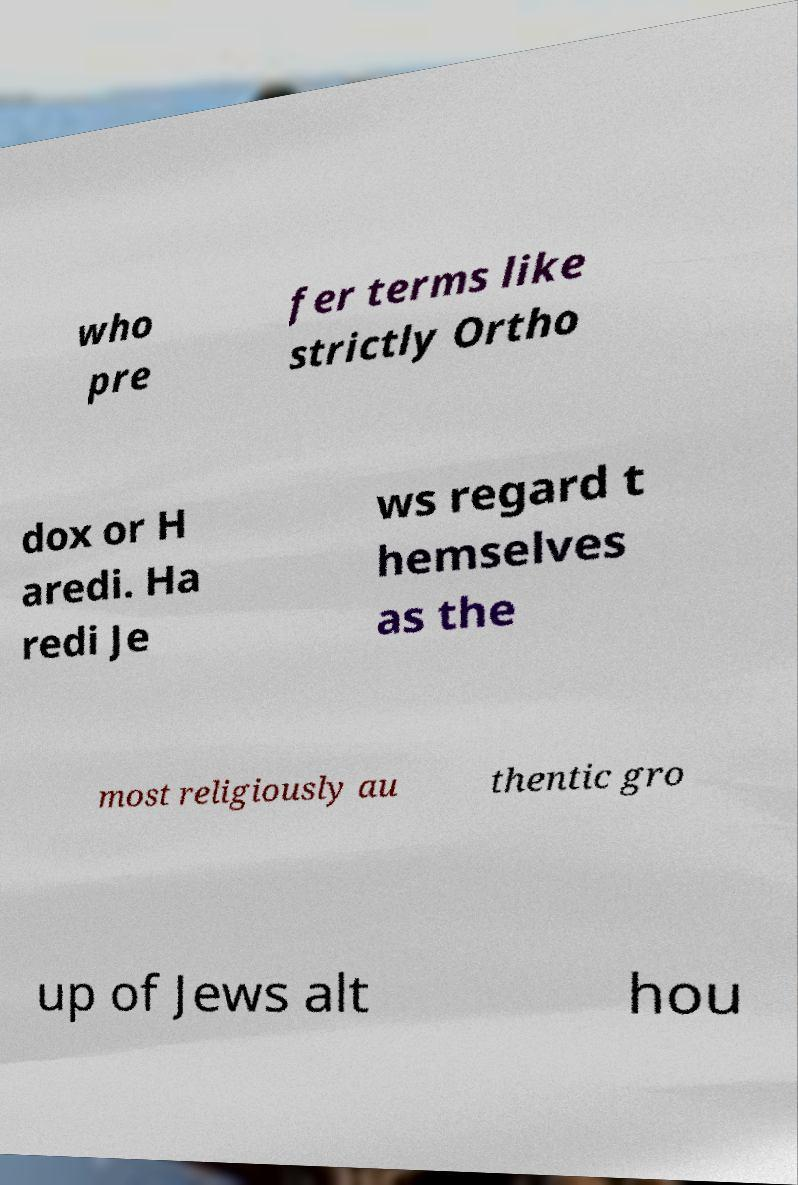Could you assist in decoding the text presented in this image and type it out clearly? who pre fer terms like strictly Ortho dox or H aredi. Ha redi Je ws regard t hemselves as the most religiously au thentic gro up of Jews alt hou 